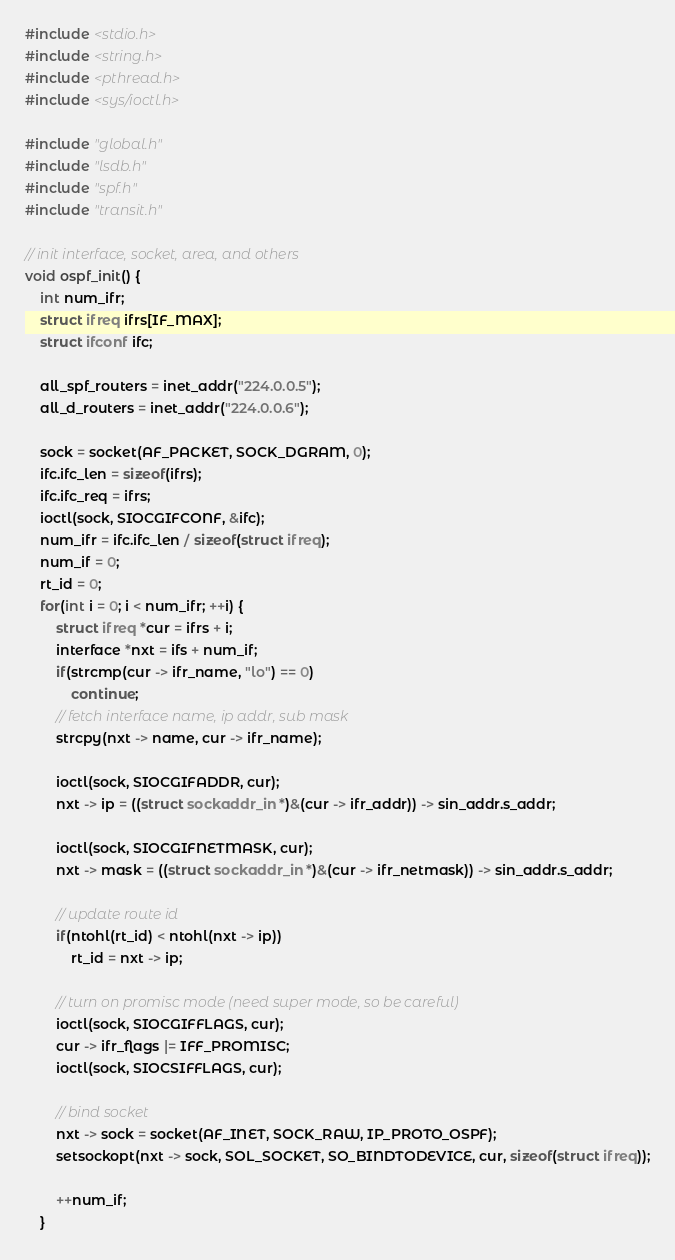<code> <loc_0><loc_0><loc_500><loc_500><_C_>#include <stdio.h>
#include <string.h>
#include <pthread.h>
#include <sys/ioctl.h>

#include "global.h"
#include "lsdb.h"
#include "spf.h"
#include "transit.h"

// init interface, socket, area, and others
void ospf_init() {
	int num_ifr;
	struct ifreq ifrs[IF_MAX];
	struct ifconf ifc;

	all_spf_routers = inet_addr("224.0.0.5");
	all_d_routers = inet_addr("224.0.0.6");

	sock = socket(AF_PACKET, SOCK_DGRAM, 0);
	ifc.ifc_len = sizeof(ifrs);
	ifc.ifc_req = ifrs;
	ioctl(sock, SIOCGIFCONF, &ifc);
	num_ifr = ifc.ifc_len / sizeof(struct ifreq);
	num_if = 0;
	rt_id = 0;
	for(int i = 0; i < num_ifr; ++i) {
		struct ifreq *cur = ifrs + i;
		interface *nxt = ifs + num_if;
		if(strcmp(cur -> ifr_name, "lo") == 0)
			continue;
		// fetch interface name, ip addr, sub mask
		strcpy(nxt -> name, cur -> ifr_name);

		ioctl(sock, SIOCGIFADDR, cur);
		nxt -> ip = ((struct sockaddr_in *)&(cur -> ifr_addr)) -> sin_addr.s_addr;

		ioctl(sock, SIOCGIFNETMASK, cur);
		nxt -> mask = ((struct sockaddr_in *)&(cur -> ifr_netmask)) -> sin_addr.s_addr;

		// update route id
		if(ntohl(rt_id) < ntohl(nxt -> ip))
			rt_id = nxt -> ip;

		// turn on promisc mode (need super mode, so be careful)
		ioctl(sock, SIOCGIFFLAGS, cur);
		cur -> ifr_flags |= IFF_PROMISC;
		ioctl(sock, SIOCSIFFLAGS, cur);

		// bind socket
		nxt -> sock = socket(AF_INET, SOCK_RAW, IP_PROTO_OSPF);
		setsockopt(nxt -> sock, SOL_SOCKET, SO_BINDTODEVICE, cur, sizeof(struct ifreq));

		++num_if;
	}</code> 